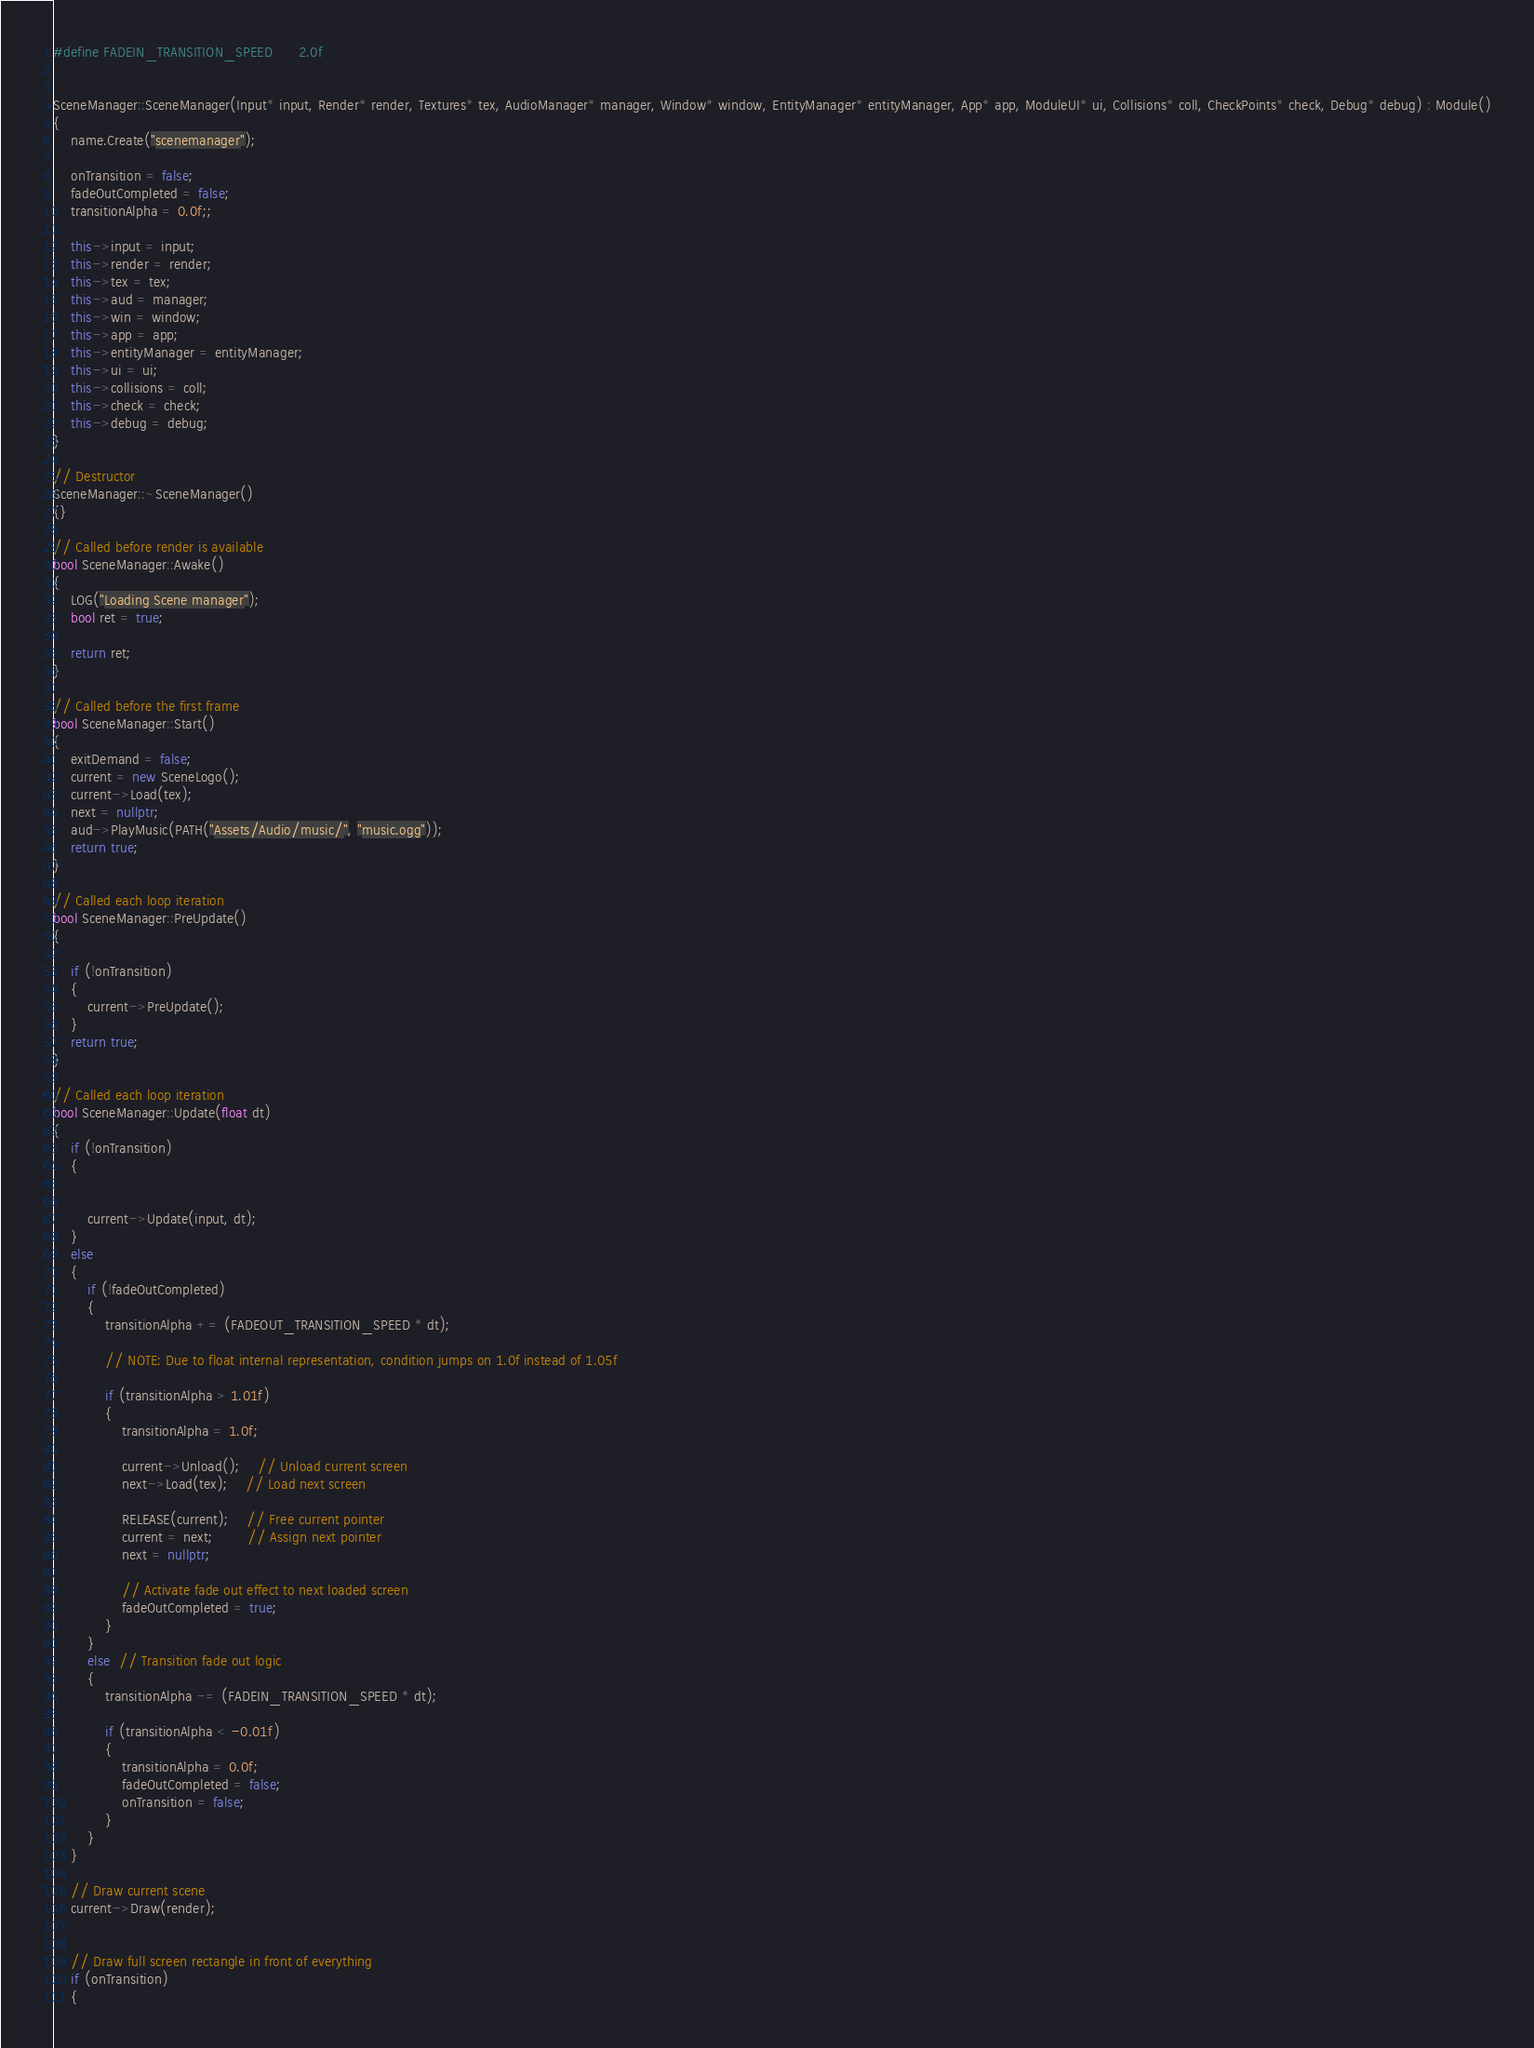Convert code to text. <code><loc_0><loc_0><loc_500><loc_500><_C++_>#define FADEIN_TRANSITION_SPEED		2.0f


SceneManager::SceneManager(Input* input, Render* render, Textures* tex, AudioManager* manager, Window* window, EntityManager* entityManager, App* app, ModuleUI* ui, Collisions* coll, CheckPoints* check, Debug* debug) : Module()
{
	name.Create("scenemanager");

	onTransition = false;
	fadeOutCompleted = false;
	transitionAlpha = 0.0f;;

	this->input = input;
	this->render = render;
	this->tex = tex;
	this->aud = manager;
	this->win = window;
	this->app = app;
	this->entityManager = entityManager;
	this->ui = ui;
	this->collisions = coll;
	this->check = check;
	this->debug = debug;
}

// Destructor
SceneManager::~SceneManager()
{}

// Called before render is available
bool SceneManager::Awake()
{
	LOG("Loading Scene manager");
	bool ret = true;

	return ret;
}

// Called before the first frame
bool SceneManager::Start()
{
	exitDemand = false;
	current = new SceneLogo();
	current->Load(tex);
	next = nullptr;
	aud->PlayMusic(PATH("Assets/Audio/music/", "music.ogg"));
	return true;
}

// Called each loop iteration
bool SceneManager::PreUpdate()
{

	if (!onTransition)
	{
		current->PreUpdate();
	}
	return true;
}

// Called each loop iteration
bool SceneManager::Update(float dt)
{
	if (!onTransition)
	{
	

		current->Update(input, dt);
	}
	else
	{
		if (!fadeOutCompleted)
		{
			transitionAlpha += (FADEOUT_TRANSITION_SPEED * dt);

			// NOTE: Due to float internal representation, condition jumps on 1.0f instead of 1.05f

			if (transitionAlpha > 1.01f)
			{
				transitionAlpha = 1.0f;

				current->Unload();	// Unload current screen
				next->Load(tex);	// Load next screen

				RELEASE(current);	// Free current pointer
				current = next;		// Assign next pointer
				next = nullptr;

				// Activate fade out effect to next loaded screen
				fadeOutCompleted = true;
			}
		}
		else  // Transition fade out logic
		{
			transitionAlpha -= (FADEIN_TRANSITION_SPEED * dt);

			if (transitionAlpha < -0.01f)
			{
				transitionAlpha = 0.0f;
				fadeOutCompleted = false;
				onTransition = false;
			}
		}
	}

	// Draw current scene
	current->Draw(render);
	
	
	// Draw full screen rectangle in front of everything
	if (onTransition)
	{</code> 